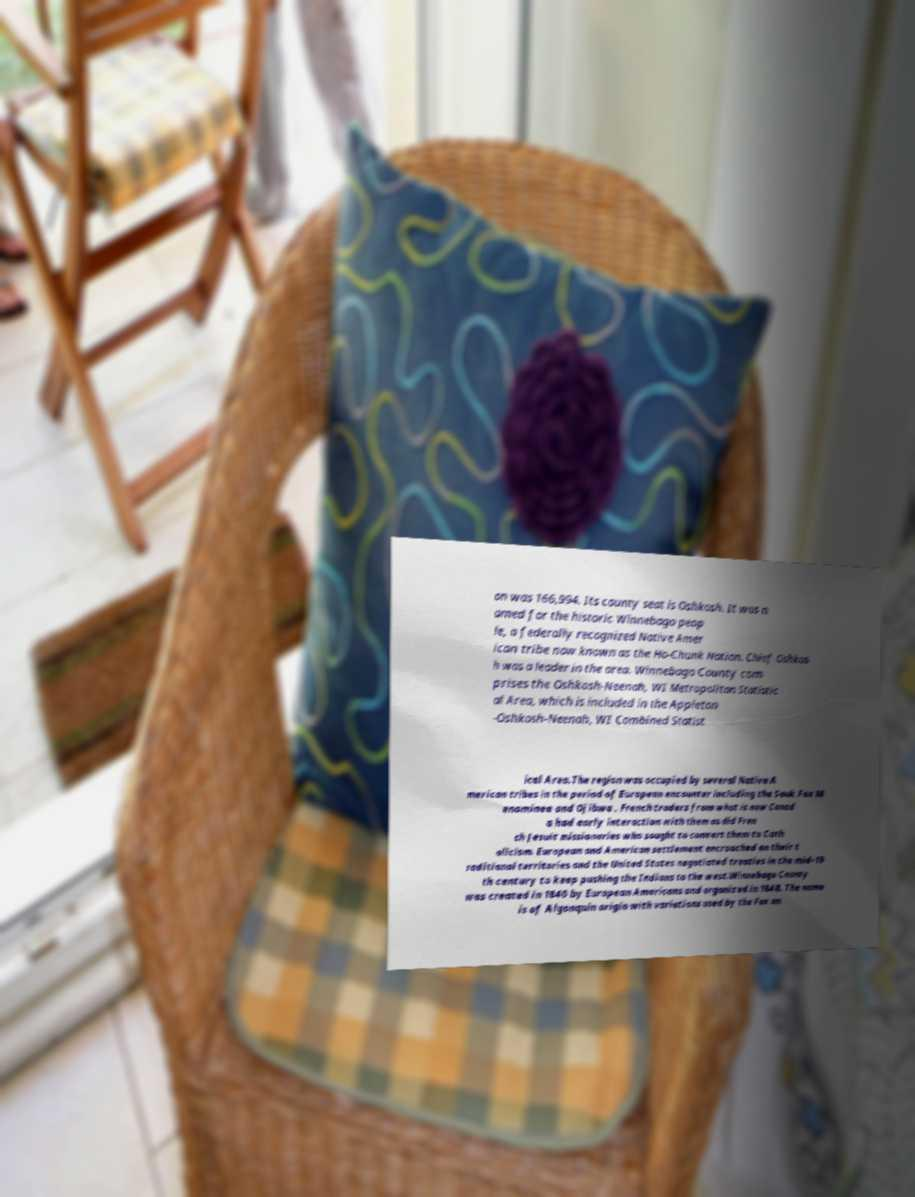Please read and relay the text visible in this image. What does it say? on was 166,994. Its county seat is Oshkosh. It was n amed for the historic Winnebago peop le, a federally recognized Native Amer ican tribe now known as the Ho-Chunk Nation. Chief Oshkos h was a leader in the area. Winnebago County com prises the Oshkosh-Neenah, WI Metropolitan Statistic al Area, which is included in the Appleton -Oshkosh-Neenah, WI Combined Statist ical Area.The region was occupied by several Native A merican tribes in the period of European encounter including the Sauk Fox M enominee and Ojibwa . French traders from what is now Canad a had early interaction with them as did Fren ch Jesuit missionaries who sought to convert them to Cath olicism. European and American settlement encroached on their t raditional territories and the United States negotiated treaties in the mid-19 th century to keep pushing the Indians to the west.Winnebago County was created in 1840 by European Americans and organized in 1848. The name is of Algonquin origin with variations used by the Fox an 